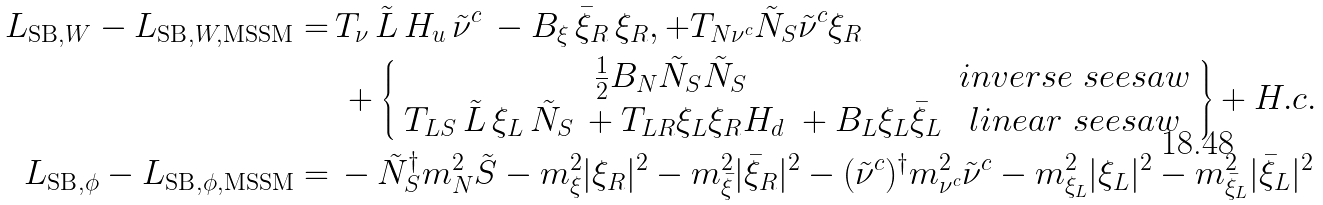<formula> <loc_0><loc_0><loc_500><loc_500>L _ { \text {SB} , W } - L _ { \text {SB} , W , \text {MSSM} } = \, & T _ { \nu } \, \tilde { L } \, H _ { u } \, \tilde { \nu } ^ { c } \, - B _ { \xi } \, \bar { \xi } _ { R } \, \xi _ { R } , + T _ { N \nu ^ { c } } { \tilde { N } } _ { S } \tilde { \nu } ^ { c } \xi _ { R } \\ & \, + \left \{ \begin{array} { c c } \frac { 1 } { 2 } B _ { N } { \tilde { N } } _ { S } { \tilde { N } } _ { S } \, & i n v e r s e \ s e e s a w \\ T _ { L S } \, { \tilde { L } } \, { \xi } _ { L } \, \tilde { N } _ { S } \, + T _ { L R } \xi _ { L } \xi _ { R } H _ { d } \ + B _ { L } \xi _ { L } \bar { \xi } _ { L } & l i n e a r \ s e e s a w \end{array} \right \} + H . c . \\ L _ { \text {SB} , \phi } - L _ { \text {SB} , \phi , \text {MSSM} } = \, & - { \tilde { N } } _ { S } ^ { \dagger } m _ { N } ^ { 2 } \tilde { S } - m _ { \xi } ^ { 2 } | \xi _ { R } | ^ { 2 } - m _ { \bar { \xi } } ^ { 2 } | \bar { \xi } _ { R } | ^ { 2 } - ( \tilde { \nu } ^ { c } ) ^ { \dagger } { m _ { \nu ^ { c } } ^ { 2 } } \tilde { \nu } ^ { c } - m _ { \xi _ { L } } ^ { 2 } | \xi _ { L } | ^ { 2 } - m _ { \bar { \xi } _ { L } } ^ { 2 } | \bar { \xi } _ { L } | ^ { 2 }</formula> 